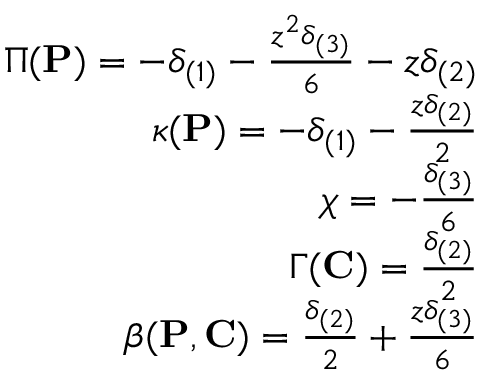Convert formula to latex. <formula><loc_0><loc_0><loc_500><loc_500>\begin{array} { r } { \Pi ( { P } ) = - \delta _ { ( 1 ) } - \frac { z ^ { 2 } \delta _ { ( 3 ) } } { 6 } - z \delta _ { ( 2 ) } } \\ { \kappa ( { P } ) = - \delta _ { ( 1 ) } - \frac { z \delta _ { ( 2 ) } } { 2 } } \\ { \chi = - \frac { \delta _ { ( 3 ) } } { 6 } } \\ { \Gamma ( { C } ) = \frac { \delta _ { ( 2 ) } } { 2 } } \\ { \beta ( { P } , { C } ) = \frac { \delta _ { ( 2 ) } } { 2 } + \frac { z \delta _ { ( 3 ) } } { 6 } } \end{array}</formula> 